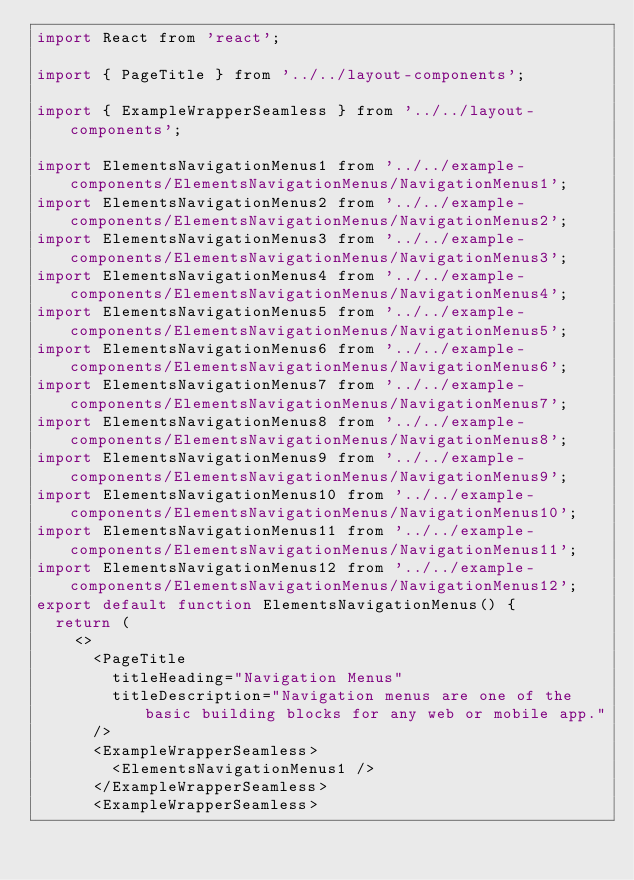<code> <loc_0><loc_0><loc_500><loc_500><_JavaScript_>import React from 'react';

import { PageTitle } from '../../layout-components';

import { ExampleWrapperSeamless } from '../../layout-components';

import ElementsNavigationMenus1 from '../../example-components/ElementsNavigationMenus/NavigationMenus1';
import ElementsNavigationMenus2 from '../../example-components/ElementsNavigationMenus/NavigationMenus2';
import ElementsNavigationMenus3 from '../../example-components/ElementsNavigationMenus/NavigationMenus3';
import ElementsNavigationMenus4 from '../../example-components/ElementsNavigationMenus/NavigationMenus4';
import ElementsNavigationMenus5 from '../../example-components/ElementsNavigationMenus/NavigationMenus5';
import ElementsNavigationMenus6 from '../../example-components/ElementsNavigationMenus/NavigationMenus6';
import ElementsNavigationMenus7 from '../../example-components/ElementsNavigationMenus/NavigationMenus7';
import ElementsNavigationMenus8 from '../../example-components/ElementsNavigationMenus/NavigationMenus8';
import ElementsNavigationMenus9 from '../../example-components/ElementsNavigationMenus/NavigationMenus9';
import ElementsNavigationMenus10 from '../../example-components/ElementsNavigationMenus/NavigationMenus10';
import ElementsNavigationMenus11 from '../../example-components/ElementsNavigationMenus/NavigationMenus11';
import ElementsNavigationMenus12 from '../../example-components/ElementsNavigationMenus/NavigationMenus12';
export default function ElementsNavigationMenus() {
  return (
    <>
      <PageTitle
        titleHeading="Navigation Menus"
        titleDescription="Navigation menus are one of the basic building blocks for any web or mobile app."
      />
      <ExampleWrapperSeamless>
        <ElementsNavigationMenus1 />
      </ExampleWrapperSeamless>
      <ExampleWrapperSeamless></code> 